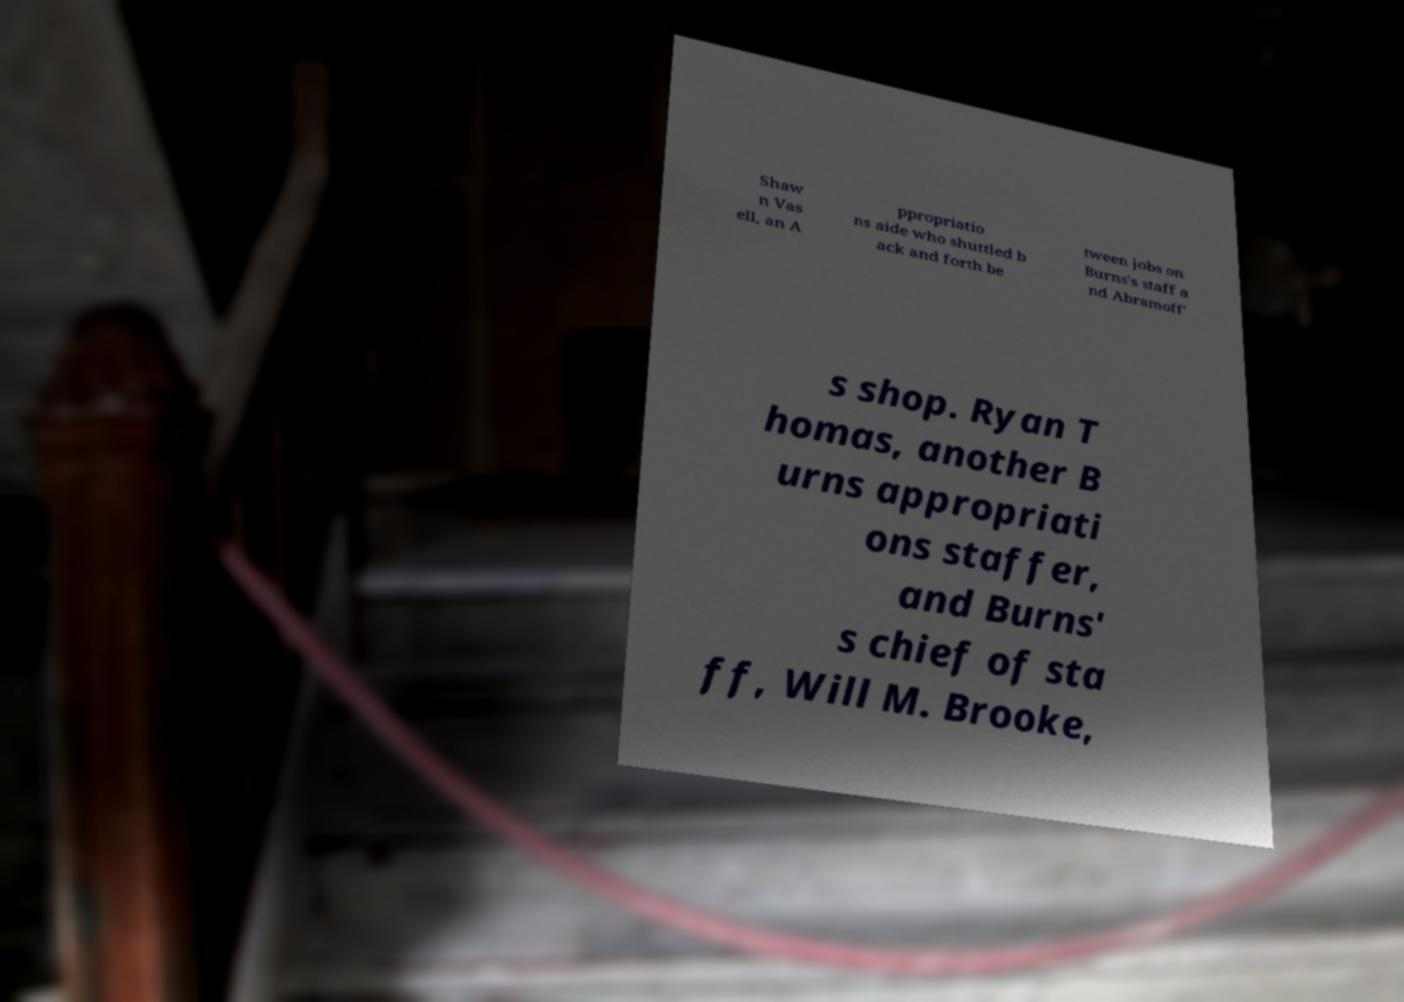Can you accurately transcribe the text from the provided image for me? Shaw n Vas ell, an A ppropriatio ns aide who shuttled b ack and forth be tween jobs on Burns's staff a nd Abramoff' s shop. Ryan T homas, another B urns appropriati ons staffer, and Burns' s chief of sta ff, Will M. Brooke, 